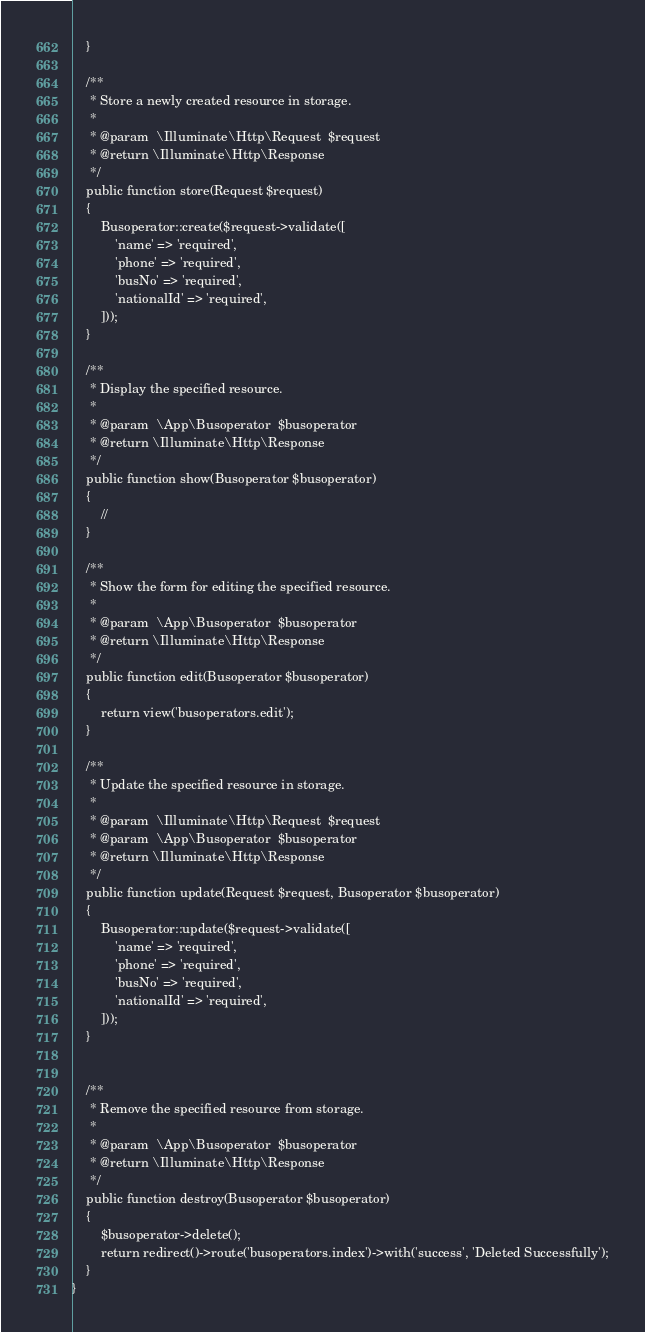Convert code to text. <code><loc_0><loc_0><loc_500><loc_500><_PHP_>    }

    /**
     * Store a newly created resource in storage.
     *
     * @param  \Illuminate\Http\Request  $request
     * @return \Illuminate\Http\Response
     */
    public function store(Request $request)
    {
        Busoperator::create($request->validate([
            'name' => 'required',
            'phone' => 'required',
            'busNo' => 'required',
            'nationalId' => 'required',
        ]));
    }

    /**
     * Display the specified resource.
     *
     * @param  \App\Busoperator  $busoperator
     * @return \Illuminate\Http\Response
     */
    public function show(Busoperator $busoperator)
    {
        //
    }

    /**
     * Show the form for editing the specified resource.
     *
     * @param  \App\Busoperator  $busoperator
     * @return \Illuminate\Http\Response
     */
    public function edit(Busoperator $busoperator)
    {
        return view('busoperators.edit');
    }

    /**
     * Update the specified resource in storage.
     *
     * @param  \Illuminate\Http\Request  $request
     * @param  \App\Busoperator  $busoperator
     * @return \Illuminate\Http\Response
     */
    public function update(Request $request, Busoperator $busoperator)
    {
        Busoperator::update($request->validate([
            'name' => 'required',
            'phone' => 'required',
            'busNo' => 'required',
            'nationalId' => 'required',
        ]));
    }
    

    /**
     * Remove the specified resource from storage.
     *
     * @param  \App\Busoperator  $busoperator
     * @return \Illuminate\Http\Response
     */
    public function destroy(Busoperator $busoperator)
    {
        $busoperator->delete();
        return redirect()->route('busoperators.index')->with('success', 'Deleted Successfully');
    }
}
</code> 